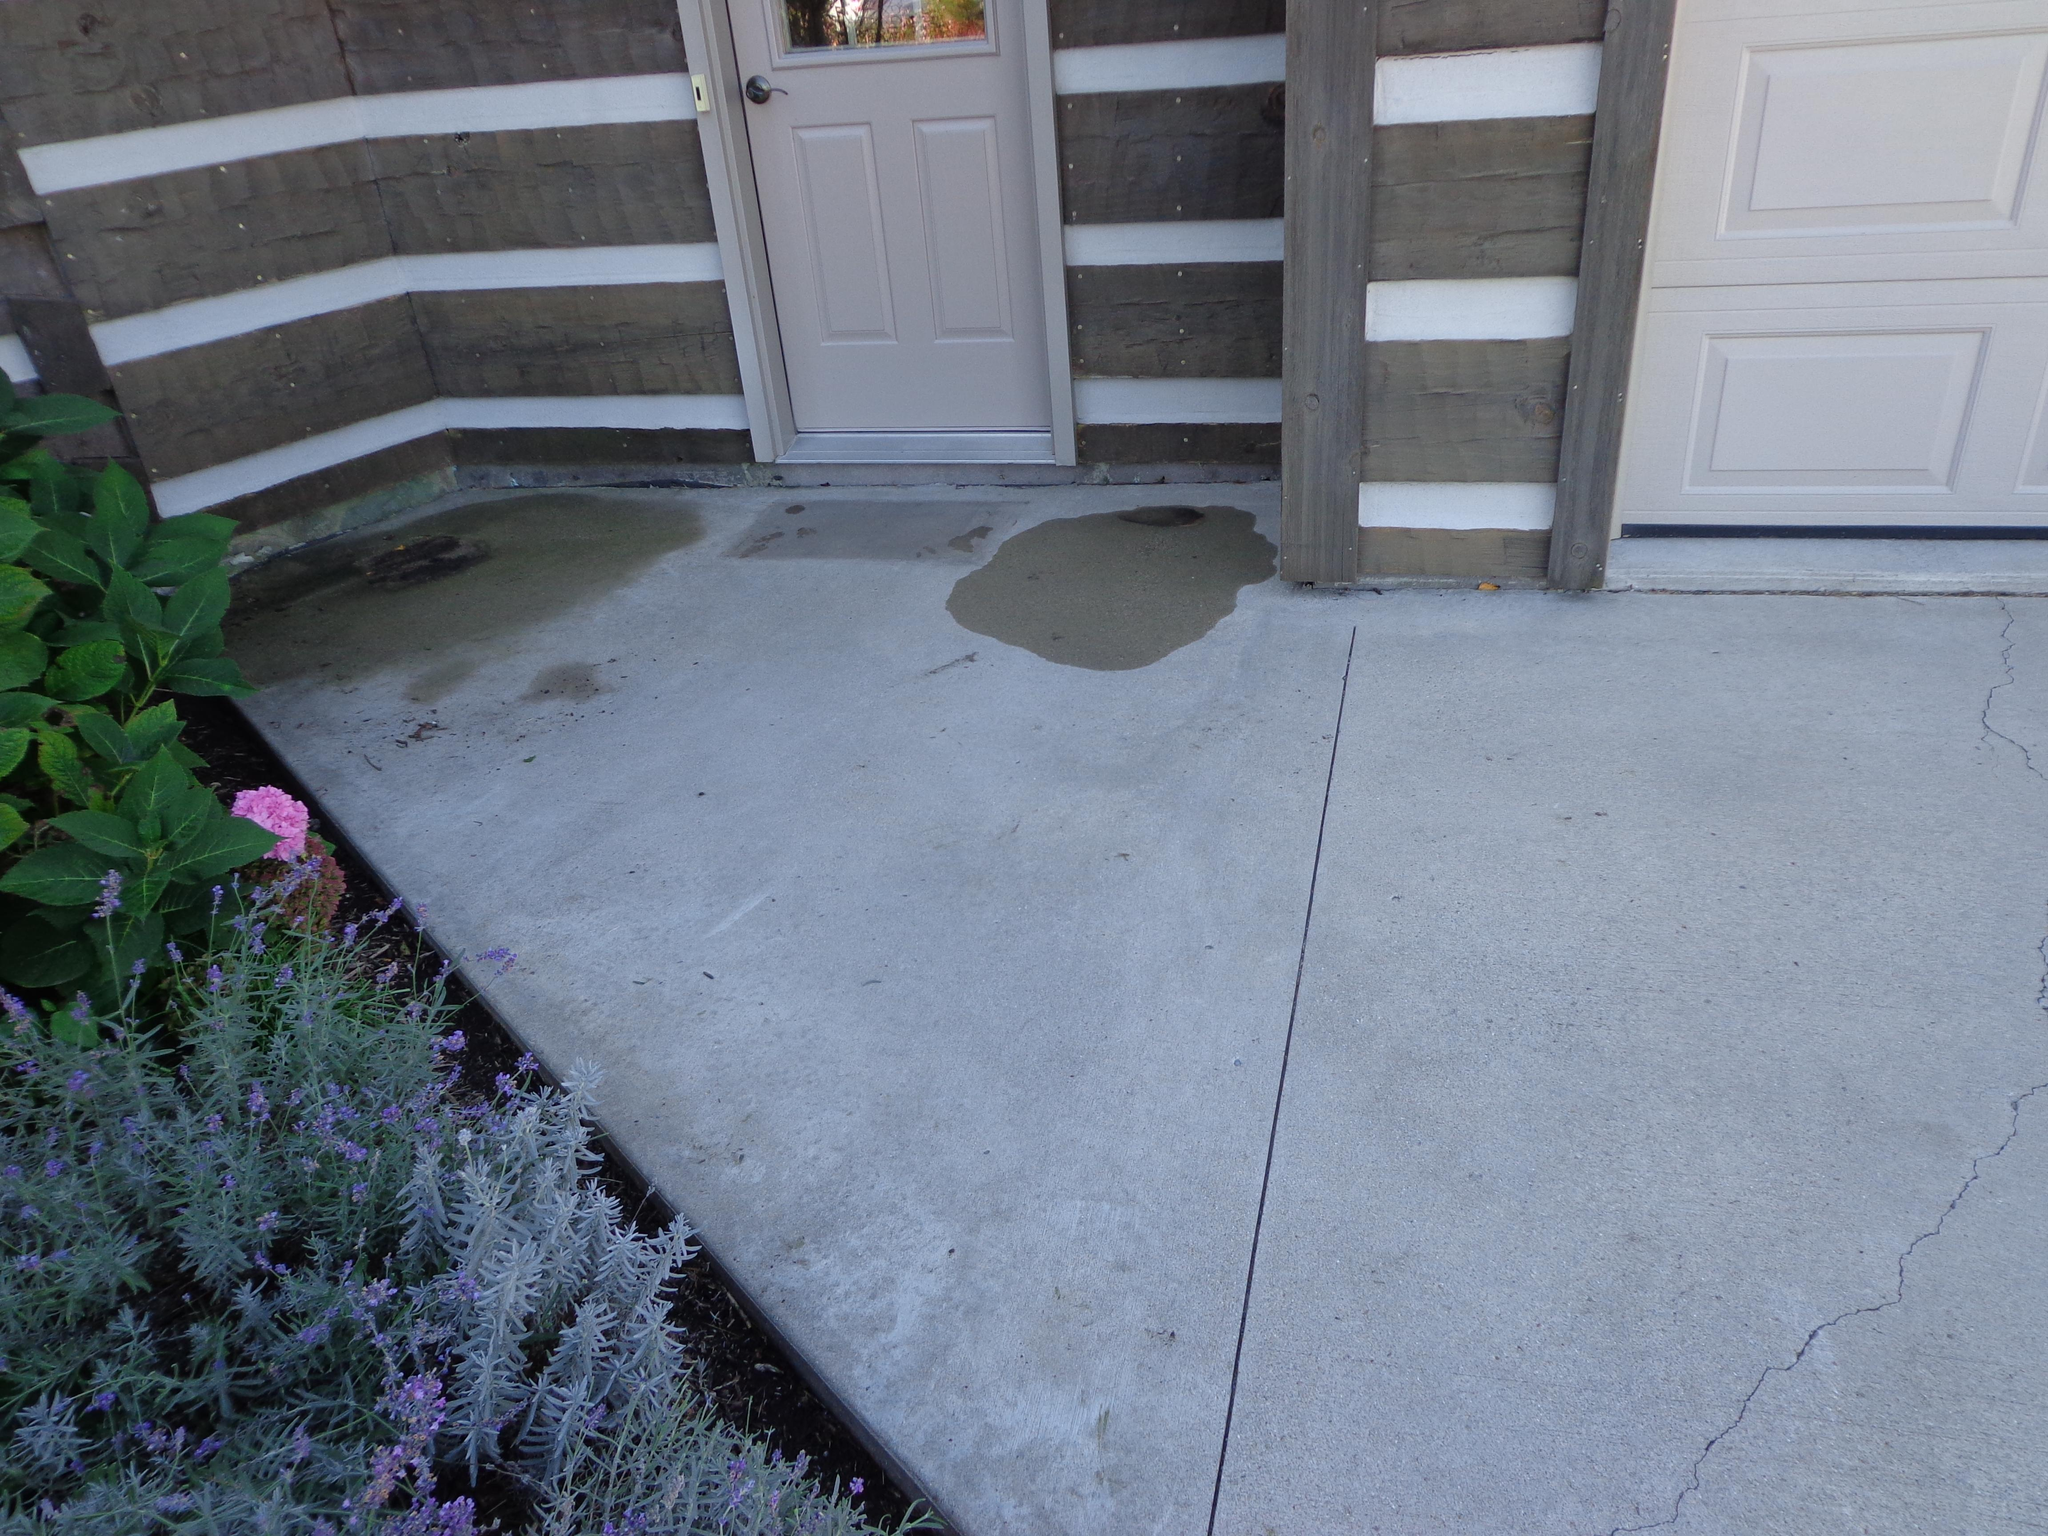What type of vegetation is on the left side of the image? There are plants on the left side of the image. Can you describe any specific floral elements in the image? Yes, there is a flower in the image. What architectural feature is located in the center of the image? There are doors in the center of the image. What type of structure is visible in the image? There is a wall in the image. Where is the crown placed in the image? There is no crown present in the image. What type of fruit can be seen hanging from the wall in the image? There are no fruits, including oranges, depicted in the image. 